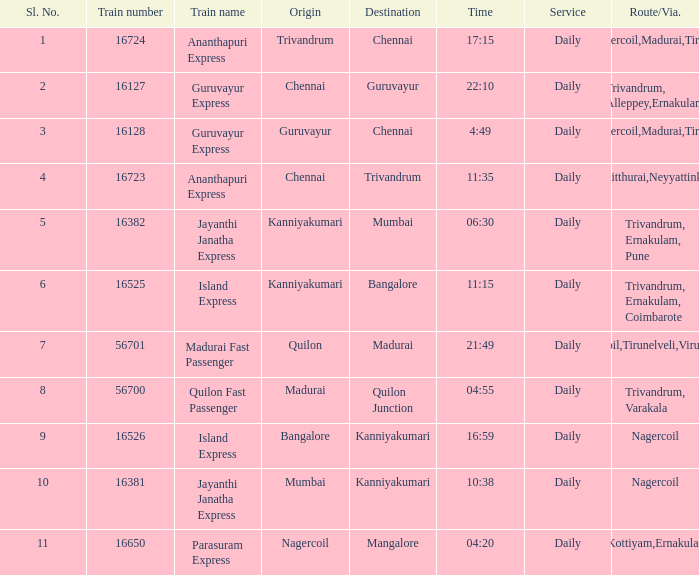What is the route/via when the train name is Parasuram Express? Trivandrum,Kottiyam,Ernakulam,Kozhikode. 